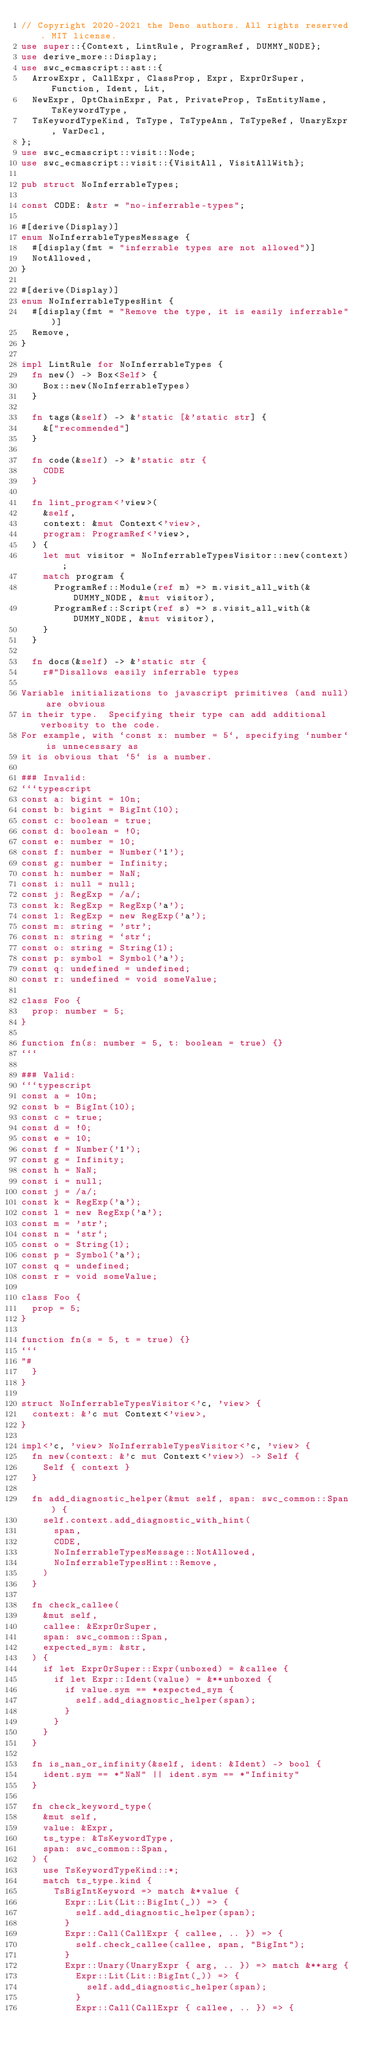<code> <loc_0><loc_0><loc_500><loc_500><_Rust_>// Copyright 2020-2021 the Deno authors. All rights reserved. MIT license.
use super::{Context, LintRule, ProgramRef, DUMMY_NODE};
use derive_more::Display;
use swc_ecmascript::ast::{
  ArrowExpr, CallExpr, ClassProp, Expr, ExprOrSuper, Function, Ident, Lit,
  NewExpr, OptChainExpr, Pat, PrivateProp, TsEntityName, TsKeywordType,
  TsKeywordTypeKind, TsType, TsTypeAnn, TsTypeRef, UnaryExpr, VarDecl,
};
use swc_ecmascript::visit::Node;
use swc_ecmascript::visit::{VisitAll, VisitAllWith};

pub struct NoInferrableTypes;

const CODE: &str = "no-inferrable-types";

#[derive(Display)]
enum NoInferrableTypesMessage {
  #[display(fmt = "inferrable types are not allowed")]
  NotAllowed,
}

#[derive(Display)]
enum NoInferrableTypesHint {
  #[display(fmt = "Remove the type, it is easily inferrable")]
  Remove,
}

impl LintRule for NoInferrableTypes {
  fn new() -> Box<Self> {
    Box::new(NoInferrableTypes)
  }

  fn tags(&self) -> &'static [&'static str] {
    &["recommended"]
  }

  fn code(&self) -> &'static str {
    CODE
  }

  fn lint_program<'view>(
    &self,
    context: &mut Context<'view>,
    program: ProgramRef<'view>,
  ) {
    let mut visitor = NoInferrableTypesVisitor::new(context);
    match program {
      ProgramRef::Module(ref m) => m.visit_all_with(&DUMMY_NODE, &mut visitor),
      ProgramRef::Script(ref s) => s.visit_all_with(&DUMMY_NODE, &mut visitor),
    }
  }

  fn docs(&self) -> &'static str {
    r#"Disallows easily inferrable types

Variable initializations to javascript primitives (and null) are obvious
in their type.  Specifying their type can add additional verbosity to the code.
For example, with `const x: number = 5`, specifying `number` is unnecessary as
it is obvious that `5` is a number.
    
### Invalid:
```typescript
const a: bigint = 10n;
const b: bigint = BigInt(10);
const c: boolean = true;
const d: boolean = !0;
const e: number = 10;
const f: number = Number('1');
const g: number = Infinity;
const h: number = NaN;
const i: null = null;
const j: RegExp = /a/;
const k: RegExp = RegExp('a');
const l: RegExp = new RegExp('a');
const m: string = 'str';
const n: string = `str`;
const o: string = String(1);
const p: symbol = Symbol('a');
const q: undefined = undefined;
const r: undefined = void someValue;

class Foo {
  prop: number = 5;
}

function fn(s: number = 5, t: boolean = true) {}
```

### Valid:
```typescript
const a = 10n;
const b = BigInt(10);
const c = true;
const d = !0;
const e = 10;
const f = Number('1');
const g = Infinity;
const h = NaN;
const i = null;
const j = /a/;
const k = RegExp('a');
const l = new RegExp('a');
const m = 'str';
const n = `str`;
const o = String(1);
const p = Symbol('a');
const q = undefined;
const r = void someValue;

class Foo {
  prop = 5;
}

function fn(s = 5, t = true) {}
```
"#
  }
}

struct NoInferrableTypesVisitor<'c, 'view> {
  context: &'c mut Context<'view>,
}

impl<'c, 'view> NoInferrableTypesVisitor<'c, 'view> {
  fn new(context: &'c mut Context<'view>) -> Self {
    Self { context }
  }

  fn add_diagnostic_helper(&mut self, span: swc_common::Span) {
    self.context.add_diagnostic_with_hint(
      span,
      CODE,
      NoInferrableTypesMessage::NotAllowed,
      NoInferrableTypesHint::Remove,
    )
  }

  fn check_callee(
    &mut self,
    callee: &ExprOrSuper,
    span: swc_common::Span,
    expected_sym: &str,
  ) {
    if let ExprOrSuper::Expr(unboxed) = &callee {
      if let Expr::Ident(value) = &**unboxed {
        if value.sym == *expected_sym {
          self.add_diagnostic_helper(span);
        }
      }
    }
  }

  fn is_nan_or_infinity(&self, ident: &Ident) -> bool {
    ident.sym == *"NaN" || ident.sym == *"Infinity"
  }

  fn check_keyword_type(
    &mut self,
    value: &Expr,
    ts_type: &TsKeywordType,
    span: swc_common::Span,
  ) {
    use TsKeywordTypeKind::*;
    match ts_type.kind {
      TsBigIntKeyword => match &*value {
        Expr::Lit(Lit::BigInt(_)) => {
          self.add_diagnostic_helper(span);
        }
        Expr::Call(CallExpr { callee, .. }) => {
          self.check_callee(callee, span, "BigInt");
        }
        Expr::Unary(UnaryExpr { arg, .. }) => match &**arg {
          Expr::Lit(Lit::BigInt(_)) => {
            self.add_diagnostic_helper(span);
          }
          Expr::Call(CallExpr { callee, .. }) => {</code> 